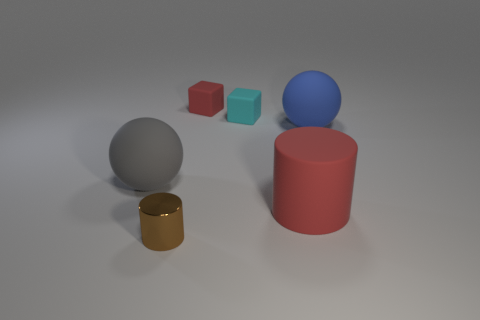Add 3 rubber spheres. How many objects exist? 9 Subtract all cylinders. How many objects are left? 4 Subtract 0 green cubes. How many objects are left? 6 Subtract all blue rubber blocks. Subtract all blue matte spheres. How many objects are left? 5 Add 1 red rubber things. How many red rubber things are left? 3 Add 4 large red rubber blocks. How many large red rubber blocks exist? 4 